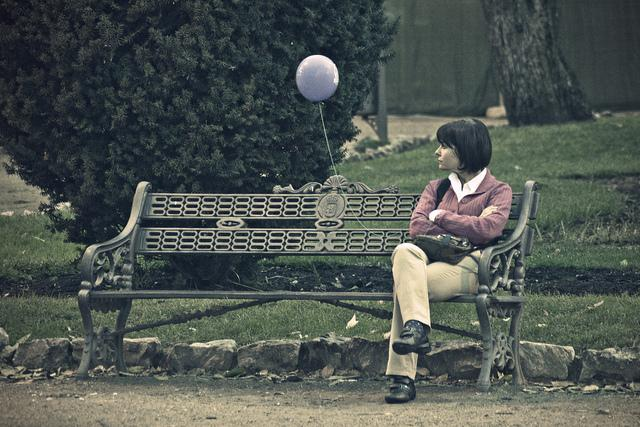What could pop that's attached to the bench? balloon 